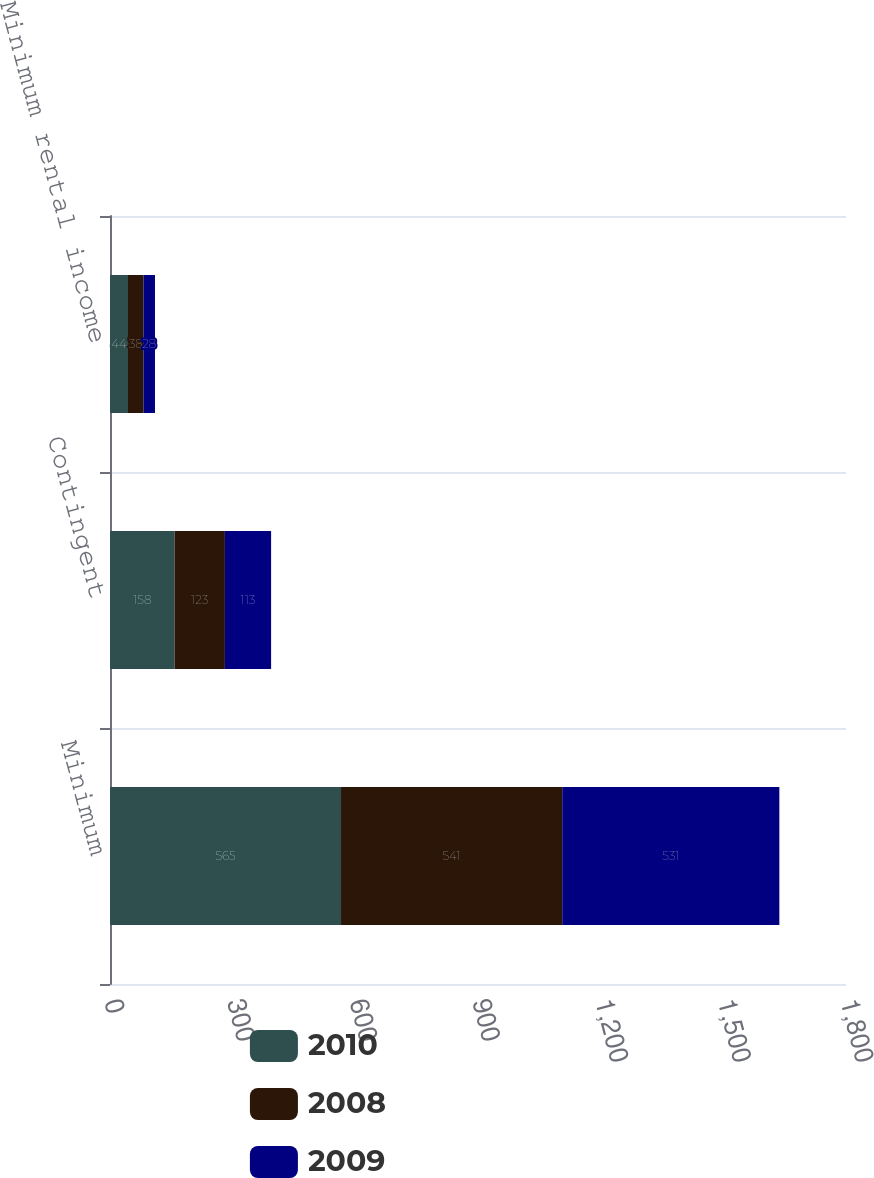Convert chart. <chart><loc_0><loc_0><loc_500><loc_500><stacked_bar_chart><ecel><fcel>Minimum<fcel>Contingent<fcel>Minimum rental income<nl><fcel>2010<fcel>565<fcel>158<fcel>44<nl><fcel>2008<fcel>541<fcel>123<fcel>38<nl><fcel>2009<fcel>531<fcel>113<fcel>28<nl></chart> 